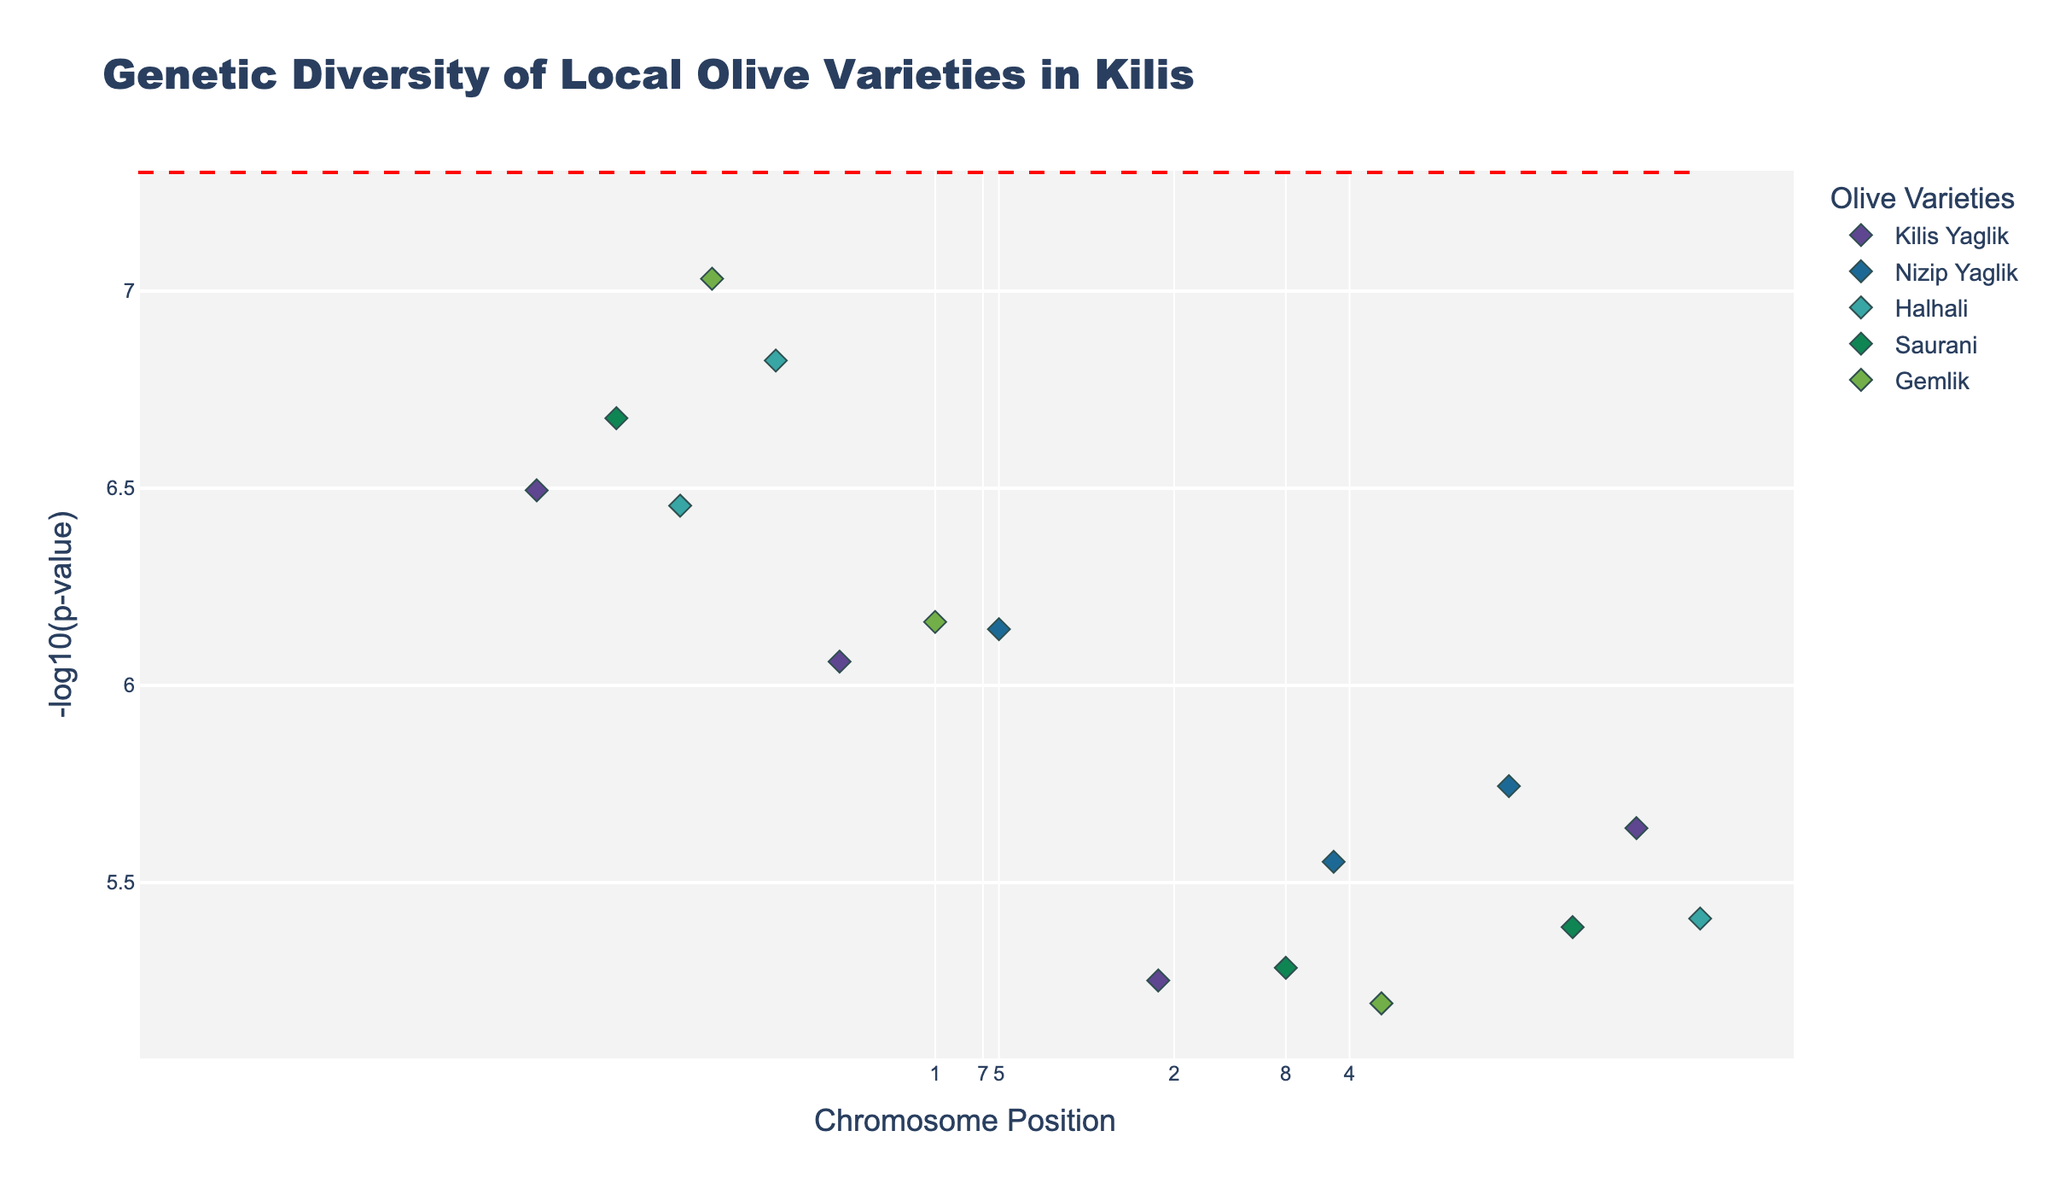What's the main title of the plot? The title is located at the top of the figure and describes the content of the plot.
Answer: Genetic Diversity of Local Olive Varieties in Kilis What does the y-axis represent? The y-axis label provides information about what is being measured on that axis.
Answer: -log10(p-value) Which chromosome has the highest -log10(p-value) for the Kilis Yaglik variety? Find the chromosome among the data points belonging to the Kilis Yaglik variety that has the highest y-axis value.
Answer: 3 How many different olive varieties are represented in the plot? Identify the unique names of the olive varieties in the legend or by different colors and markers.
Answer: 5 Compare the -log10(p-values) between chromosome 2 and chromosome 4 for the Halhali variety. Which one is higher? Locate the data points for the Halhali variety on chromosome 2 and chromosome 4, then compare their y-axis values.
Answer: Chromosome 2 Which position has the smallest p-value for the Gemlik variety? Find the position on the x-axis for the Gemlik variety where the y-axis (-log10(p-value)) is highest, as smaller p-values correspond to higher -log10(p-values).
Answer: 1800000 Are there any olive varieties with significant markers as indicated by a -log10(p-value) higher than the red dashed line? Check if any data points are above the red dashed significance line, indicating significance for any of the varieties.
Answer: Yes What's the range of positions on the x-axis? Identify the lowest and highest position values on the x-axis to describe the range.
Answer: 1250000 to 4900000 Which variety has the most markers with -log10(p-value) larger than 6? Count the number of markers for each variety that have a -log10(p-value) higher than 6 by examining the y-axis values.
Answer: No variety On chromosome 5, which variety shows the strongest association (lowest p-value)? Look at the data points on chromosome 5 and identify which variety has the highest -log10(p-value) for the strongest association.
Answer: Saurani 